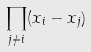<formula> <loc_0><loc_0><loc_500><loc_500>\prod _ { j \ne i } ( x _ { i } - x _ { j } )</formula> 